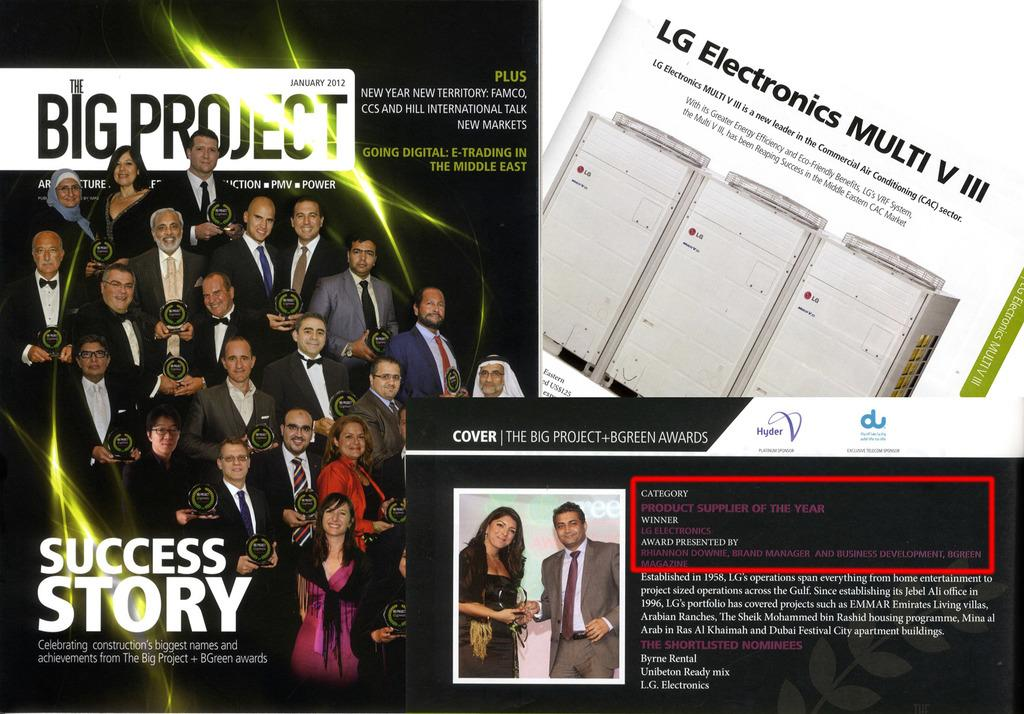<image>
Render a clear and concise summary of the photo. Big Project celebrates construction's biggest names and achievements. 